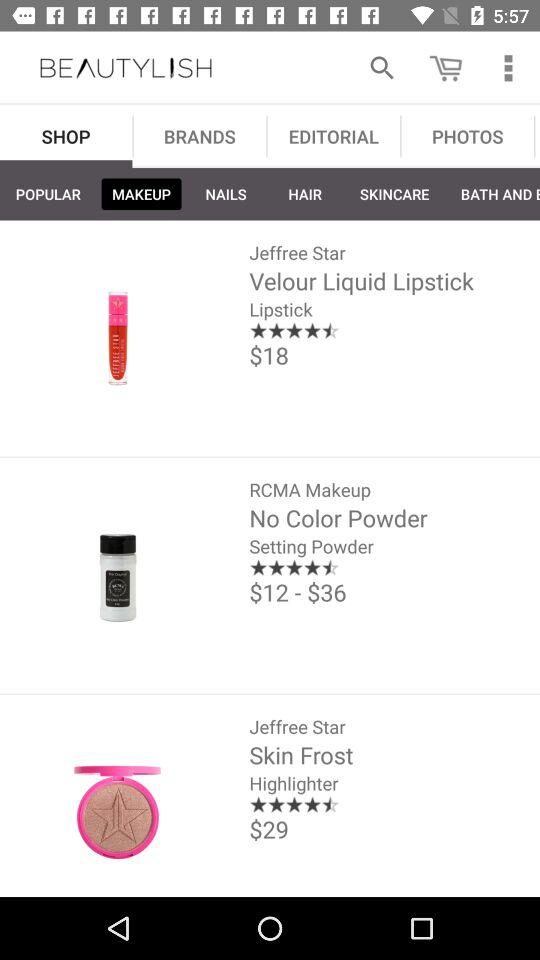What is the price of setting powder? The price of setting powder ranges from $12 to $36. 